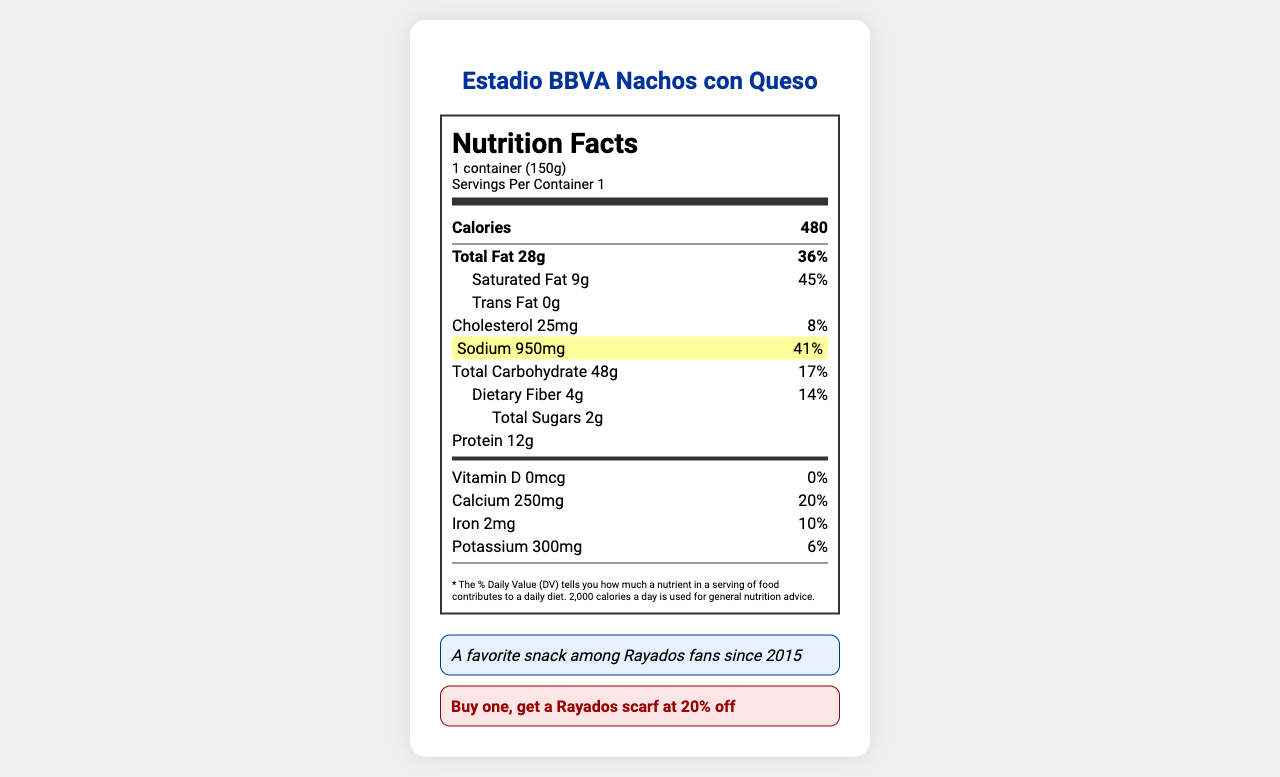What is the sodium content of the Estadio BBVA Nachos con Queso? The nutrition facts label highlights the sodium content as 950mg in the nutrient row.
Answer: 950mg How many calories are in one serving of the Estadio BBVA Nachos con Queso? The calories content is listed as 480 in the calories section of the nutrition facts.
Answer: 480 What is the serving size for Estadio BBVA Nachos con Queso? The serving size is mentioned at the top of the document as "1 container (150g)".
Answer: 1 container (150g) Which ingredient in the Estadio BBVA Nachos con Queso is an allergen? The allergens section lists "Milk" and "Soy".
Answer: Milk, Soy What percentage of the daily value is the sodium content? The sodium content as a percentage of the daily value is listed as 41%.
Answer: 41% What is the game day special for the Estadio BBVA Nachos con Queso? A. Get a free drink B. Buy one, get a Rayados scarf at 20% off C. Buy one, get another free D. Get a free dessert The document states that the game day special is "Buy one, get a Rayados scarf at 20% off".
Answer: B How much protein is in one serving of Estadio BBVA Nachos con Queso? A. 10g B. 12g C. 15g D. 20g The nutrition label states that there are 12 grams of protein per serving.
Answer: B Is there any trans fat in the Estadio BBVA Nachos con Queso? The document lists 0g of trans fat.
Answer: No Summarize the main idea of the document. The document mainly focuses on giving a comprehensive nutritional breakdown of the nachos, including detailed percentages of daily values, allergens present, ingredients used, and a special offer valid during game days.
Answer: The document is a nutrition facts label for a popular stadium snack, Estadio BBVA Nachos con Queso, detailing its serving size, calorie, fat, sodium, carbohydrate, and protein contents. It also provides information on allergens, ingredients, and a game day special offer. What is the calcium content as a percentage of the daily value? The calcium content percentage is listed as 20% in the nutrition label.
Answer: 20% When did the Estadio BBVA Nachos con Queso become a favorite among Rayados fans? The fun fact section mentions that it has been a favorite since 2015.
Answer: Since 2015 Can the document tell you where exactly in the stadium you can buy the Estadio BBVA Nachos con Queso? The document states that it is "Available at all concession stands in Estadio BBVA".
Answer: Yes How many total carbohydrates are in one serving of Estadio BBVA Nachos con Queso? The nutrition label lists the total carbohydrate content as 48 grams.
Answer: 48g What ingredients are used in the cheese sauce for the Estadio BBVA Nachos con Queso? The document does not break down the specific ingredients used in the cheese sauce but lists "Cheese sauce" as a whole.
Answer: Not enough information What is the purpose of listing "0%" next to Vitamin D in the nutrition facts? The "0%" next to Vitamin D denotes that the product does not contain any Vitamin D.
Answer: It indicates that there is no Vitamin D in the product. How much cholesterol is in the Estadio BBVA Nachos con Queso, and what percentage of the daily value does it represent? The nutrition label lists 25mg of cholesterol which represents 8% of the daily value.
Answer: 25mg, 8% 